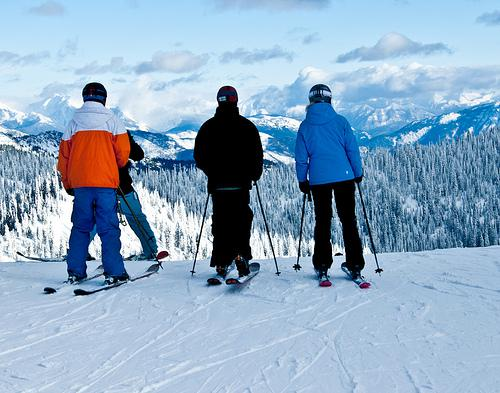Question: why are the three people carrying poles?
Choices:
A. Strippers.
B. Parade.
C. Protesting.
D. They're skiing.
Answer with the letter. Answer: D Question: how many people are in the photo?
Choices:
A. 4.
B. 7.
C. 8.
D. 9.
Answer with the letter. Answer: A Question: where are the people?
Choices:
A. Zoo.
B. At the top of a ski trail.
C. Park.
D. Carnival.
Answer with the letter. Answer: B Question: what are on the people's heads?
Choices:
A. Helmets.
B. Hat.
C. Sombrero.
D. Glasses.
Answer with the letter. Answer: A Question: who is in the photo?
Choices:
A. Ten skiers.
B. Three skiers and a snowboarder.
C. Five snowboarders.
D. Two dancers.
Answer with the letter. Answer: B Question: what color is the ground?
Choices:
A. White.
B. Red.
C. Blue.
D. Orange.
Answer with the letter. Answer: A 